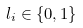Convert formula to latex. <formula><loc_0><loc_0><loc_500><loc_500>l _ { i } \in \{ 0 , 1 \}</formula> 